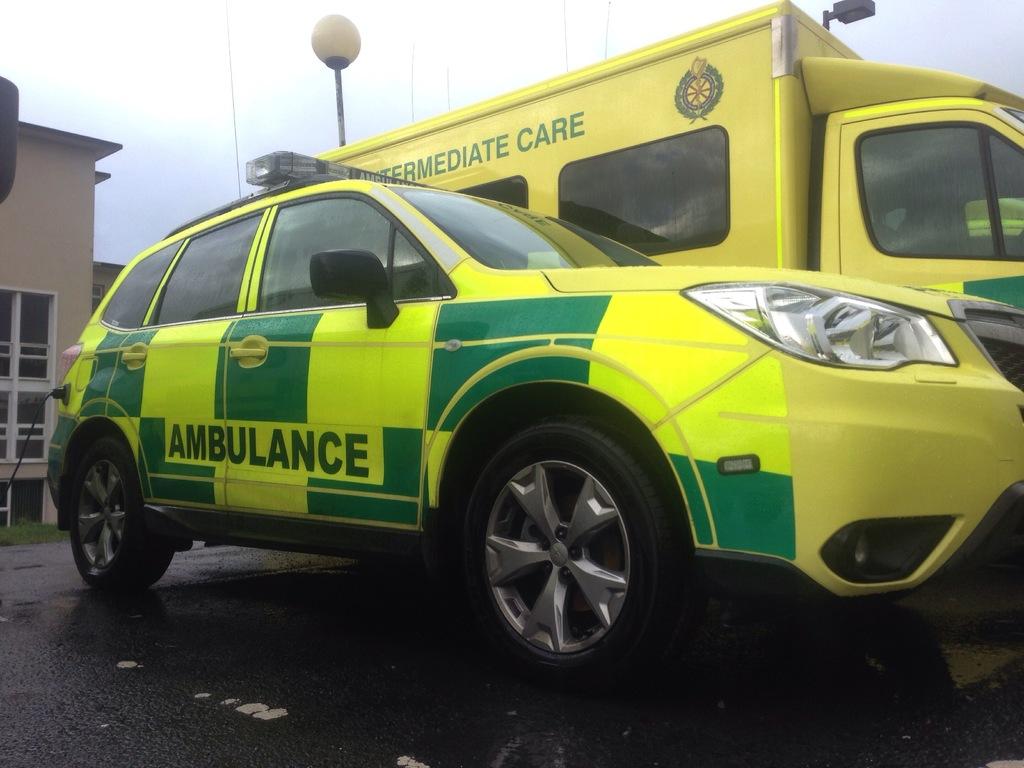What type of vehicle is this?
Offer a terse response. Ambulance. What is the word on the right of the yellow truck?
Your response must be concise. Care. 